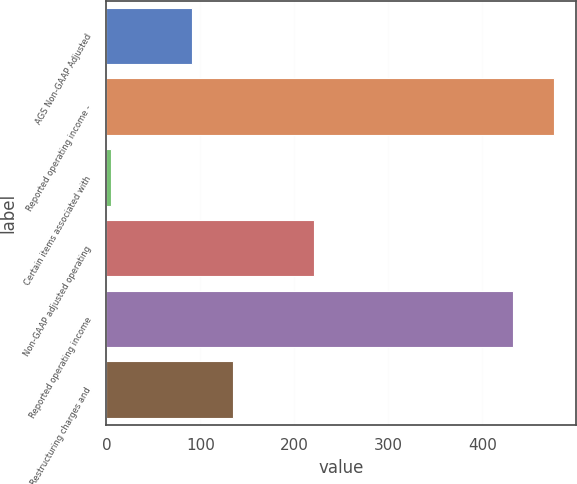Convert chart to OTSL. <chart><loc_0><loc_0><loc_500><loc_500><bar_chart><fcel>AGS Non-GAAP Adjusted<fcel>Reported operating income -<fcel>Certain items associated with<fcel>Non-GAAP adjusted operating<fcel>Reported operating income<fcel>Restructuring charges and<nl><fcel>91.2<fcel>476.1<fcel>5<fcel>220.5<fcel>433<fcel>134.3<nl></chart> 